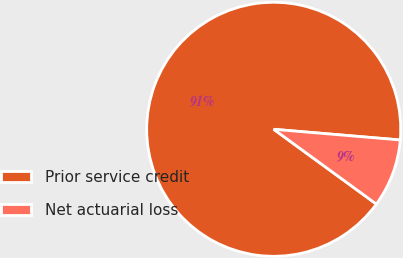<chart> <loc_0><loc_0><loc_500><loc_500><pie_chart><fcel>Prior service credit<fcel>Net actuarial loss<nl><fcel>91.32%<fcel>8.68%<nl></chart> 